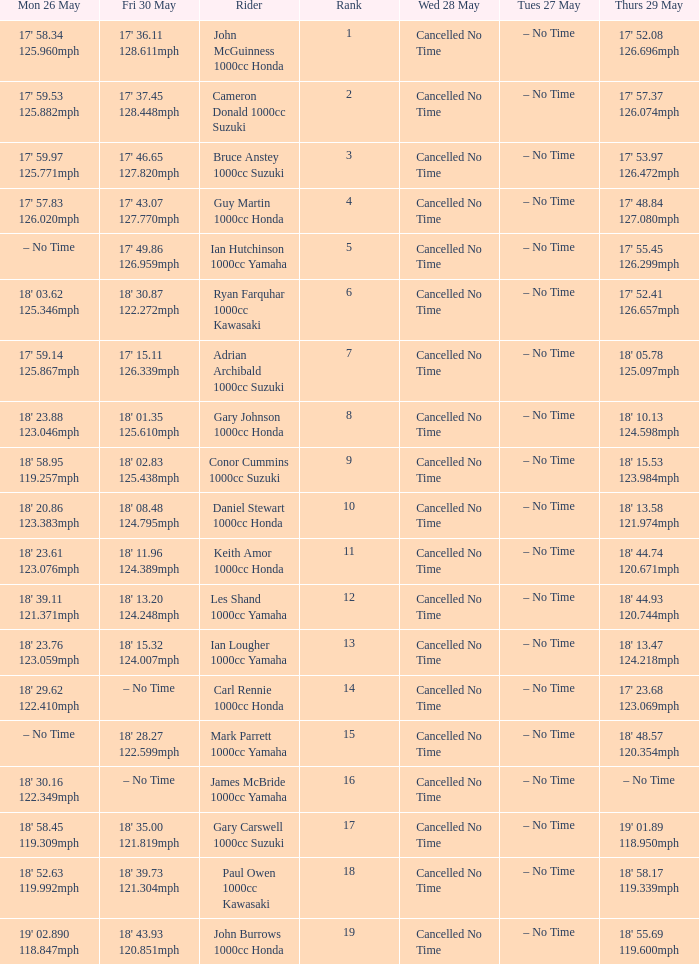What is the numbr for fri may 30 and mon may 26 is 19' 02.890 118.847mph? 18' 43.93 120.851mph. 